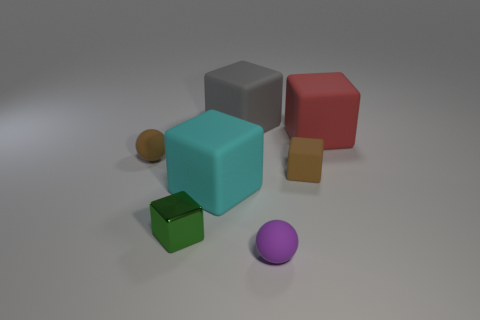There is a tiny matte object that is to the left of the tiny purple matte ball; is its color the same as the tiny rubber cube?
Keep it short and to the point. Yes. How many other objects are there of the same color as the metal block?
Offer a very short reply. 0. How many things are green metal objects or big brown metallic balls?
Provide a short and direct response. 1. What number of things are small brown things or tiny matte things that are on the left side of the big cyan block?
Provide a succinct answer. 2. Does the cyan thing have the same material as the brown sphere?
Your response must be concise. Yes. What number of other objects are the same material as the large red cube?
Your answer should be compact. 5. Are there more brown matte objects than big cyan blocks?
Keep it short and to the point. Yes. There is a brown thing to the right of the brown ball; is it the same shape as the purple thing?
Your answer should be very brief. No. Are there fewer gray objects than red metal cylinders?
Offer a very short reply. No. There is a green block that is the same size as the brown block; what is it made of?
Your answer should be very brief. Metal. 